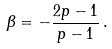<formula> <loc_0><loc_0><loc_500><loc_500>\beta = - \frac { 2 p - 1 } { p - 1 } \, .</formula> 